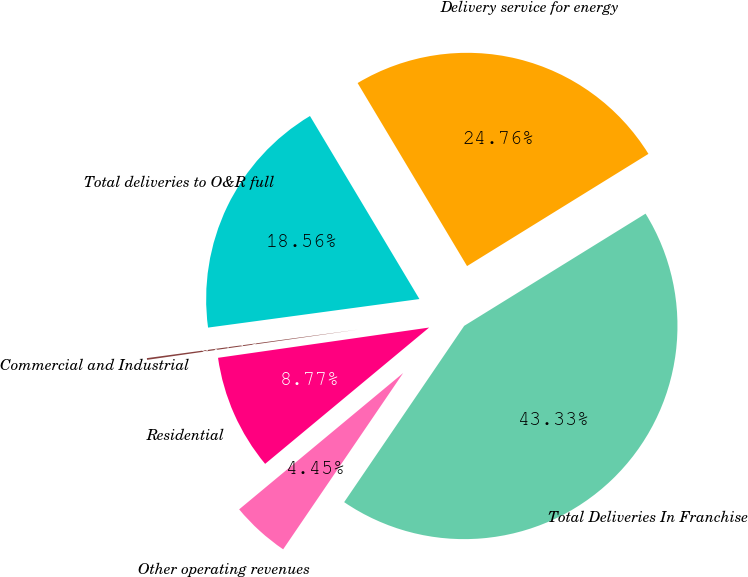<chart> <loc_0><loc_0><loc_500><loc_500><pie_chart><fcel>Total deliveries to O&R full<fcel>Delivery service for energy<fcel>Total Deliveries In Franchise<fcel>Other operating revenues<fcel>Residential<fcel>Commercial and Industrial<nl><fcel>18.56%<fcel>24.76%<fcel>43.33%<fcel>4.45%<fcel>8.77%<fcel>0.13%<nl></chart> 